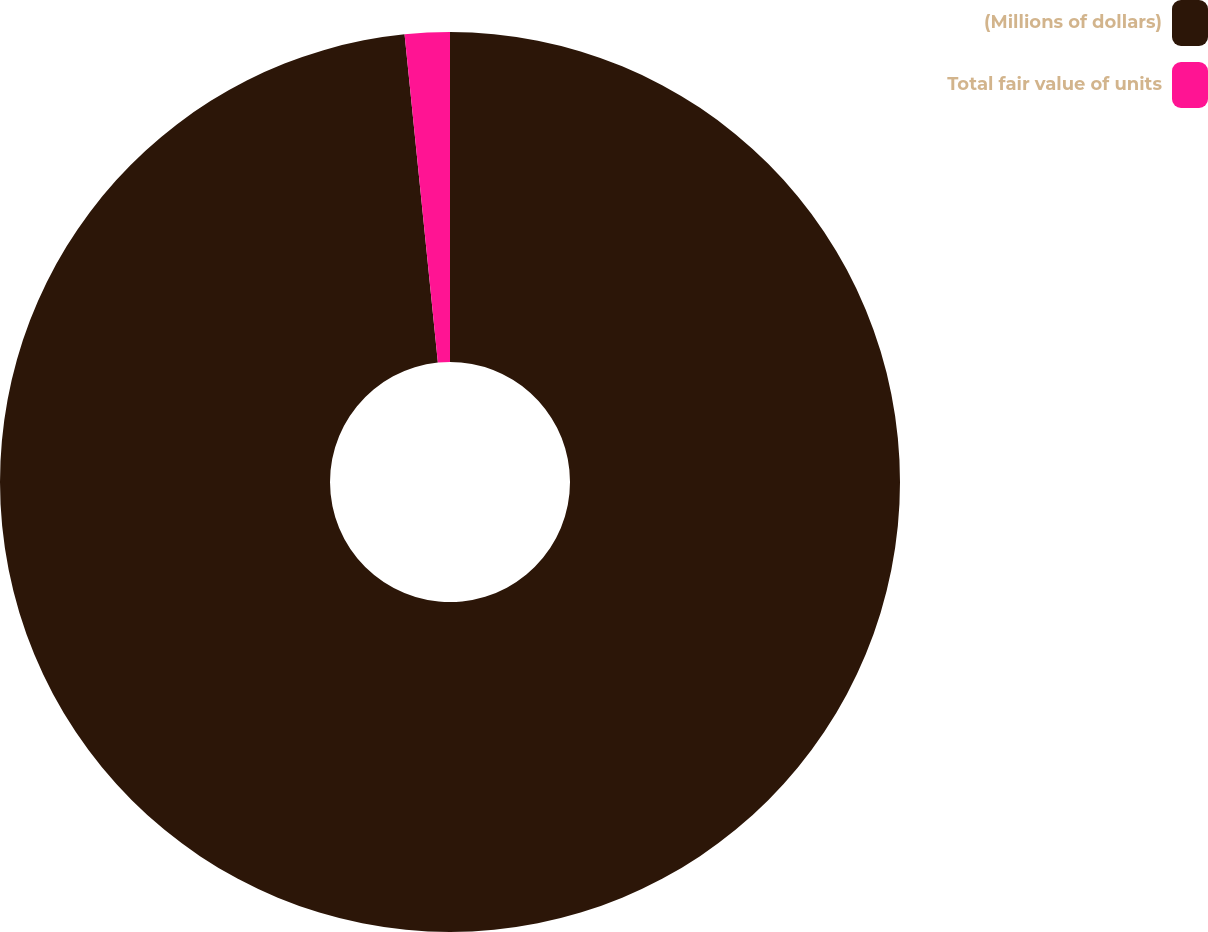Convert chart. <chart><loc_0><loc_0><loc_500><loc_500><pie_chart><fcel>(Millions of dollars)<fcel>Total fair value of units<nl><fcel>98.39%<fcel>1.61%<nl></chart> 